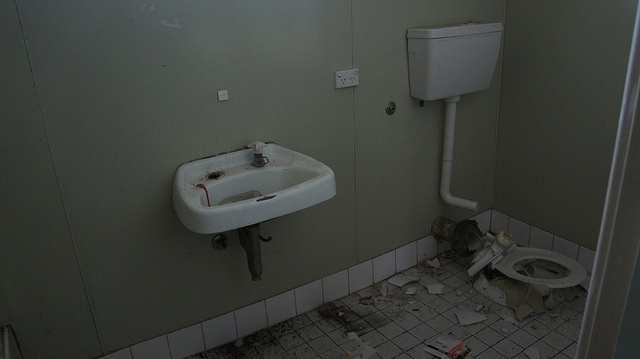Describe the objects in this image and their specific colors. I can see sink in black and gray tones and toilet in black tones in this image. 